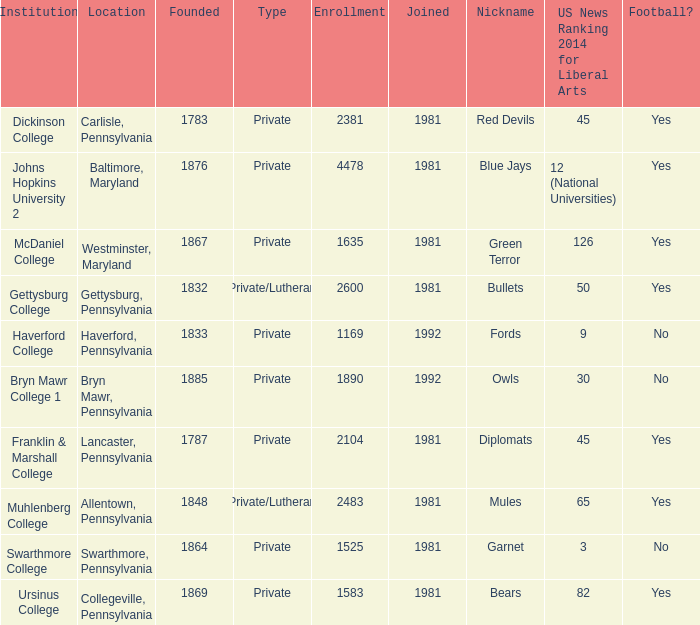What type of school is in swarthmore, pennsylvania? Private. 